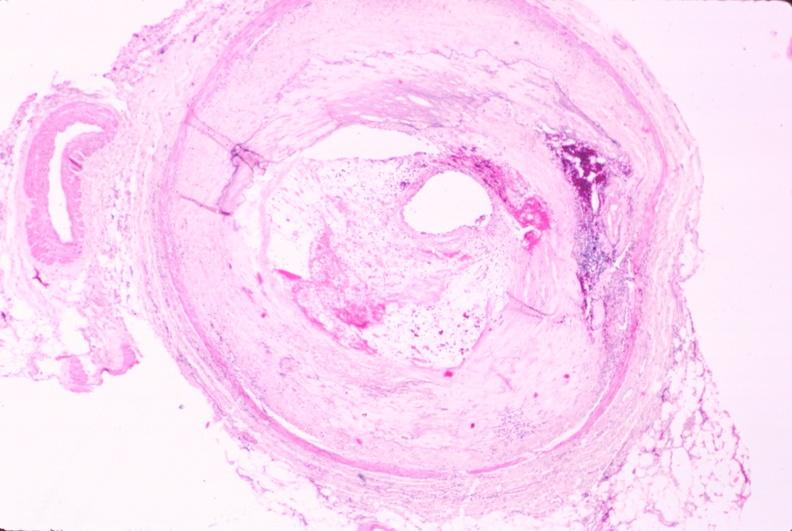how is atherosclerosis left anterior descending artery?
Answer the question using a single word or phrase. Coronary 